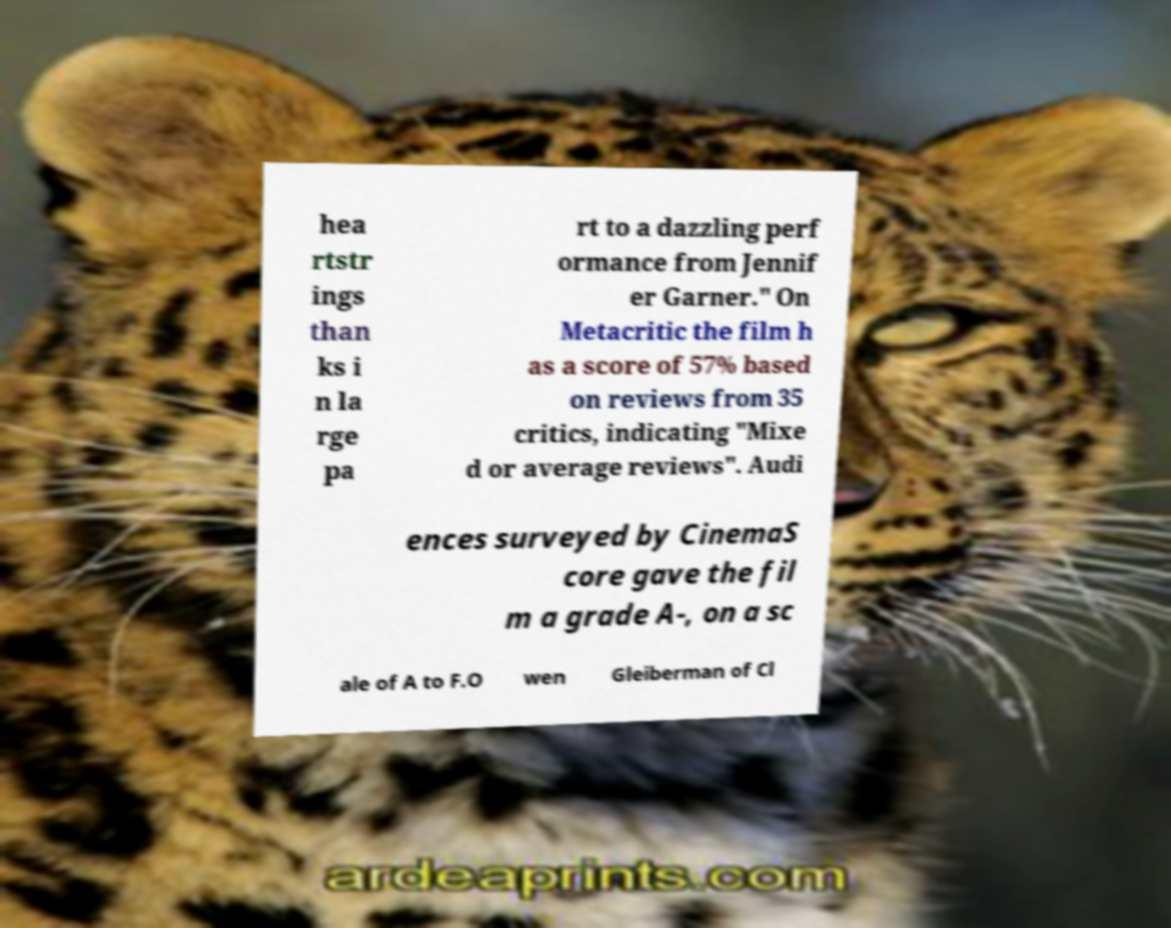What messages or text are displayed in this image? I need them in a readable, typed format. hea rtstr ings than ks i n la rge pa rt to a dazzling perf ormance from Jennif er Garner." On Metacritic the film h as a score of 57% based on reviews from 35 critics, indicating "Mixe d or average reviews". Audi ences surveyed by CinemaS core gave the fil m a grade A-, on a sc ale of A to F.O wen Gleiberman of Cl 